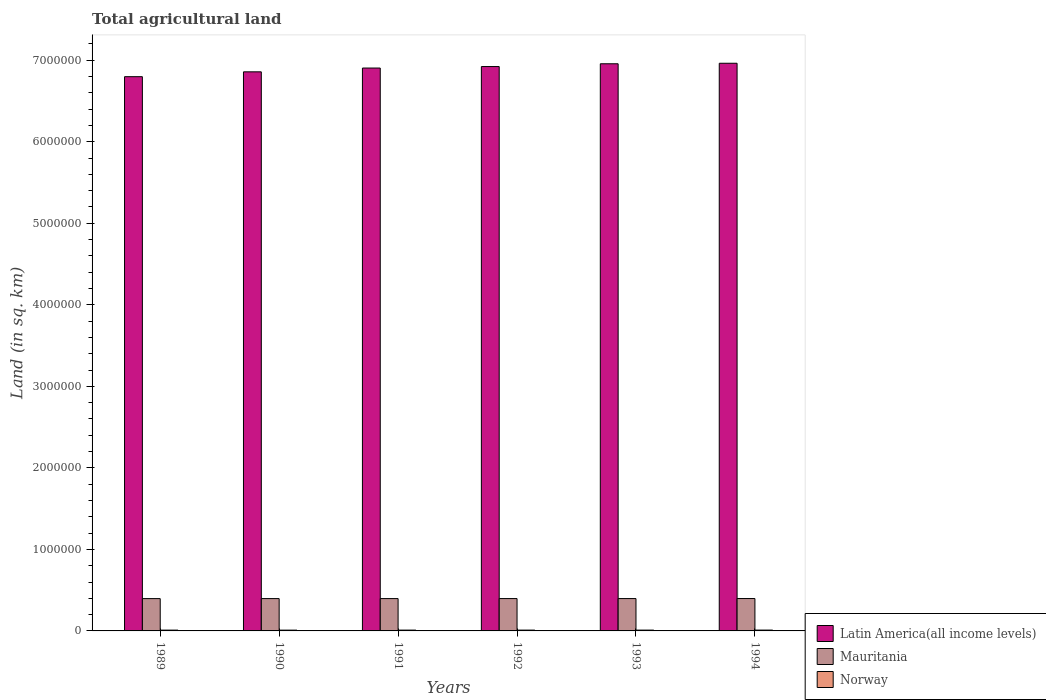How many groups of bars are there?
Keep it short and to the point. 6. How many bars are there on the 2nd tick from the left?
Offer a terse response. 3. In how many cases, is the number of bars for a given year not equal to the number of legend labels?
Make the answer very short. 0. What is the total agricultural land in Norway in 1994?
Your answer should be compact. 1.03e+04. Across all years, what is the maximum total agricultural land in Norway?
Provide a succinct answer. 1.03e+04. Across all years, what is the minimum total agricultural land in Norway?
Offer a terse response. 9760. In which year was the total agricultural land in Latin America(all income levels) minimum?
Offer a terse response. 1989. What is the total total agricultural land in Mauritania in the graph?
Provide a short and direct response. 2.38e+06. What is the difference between the total agricultural land in Latin America(all income levels) in 1990 and that in 1992?
Make the answer very short. -6.47e+04. What is the difference between the total agricultural land in Latin America(all income levels) in 1993 and the total agricultural land in Mauritania in 1990?
Keep it short and to the point. 6.56e+06. What is the average total agricultural land in Mauritania per year?
Offer a very short reply. 3.97e+05. In the year 1989, what is the difference between the total agricultural land in Mauritania and total agricultural land in Latin America(all income levels)?
Keep it short and to the point. -6.40e+06. In how many years, is the total agricultural land in Mauritania greater than 1200000 sq.km?
Provide a short and direct response. 0. What is the ratio of the total agricultural land in Latin America(all income levels) in 1990 to that in 1994?
Offer a very short reply. 0.98. Is the total agricultural land in Latin America(all income levels) in 1990 less than that in 1993?
Provide a short and direct response. Yes. What is the difference between the highest and the second highest total agricultural land in Mauritania?
Your answer should be compact. 400. What is the difference between the highest and the lowest total agricultural land in Norway?
Give a very brief answer. 540. What does the 3rd bar from the left in 1993 represents?
Your answer should be compact. Norway. What does the 1st bar from the right in 1993 represents?
Your response must be concise. Norway. Is it the case that in every year, the sum of the total agricultural land in Norway and total agricultural land in Latin America(all income levels) is greater than the total agricultural land in Mauritania?
Give a very brief answer. Yes. How many bars are there?
Give a very brief answer. 18. Are all the bars in the graph horizontal?
Make the answer very short. No. What is the difference between two consecutive major ticks on the Y-axis?
Keep it short and to the point. 1.00e+06. Are the values on the major ticks of Y-axis written in scientific E-notation?
Ensure brevity in your answer.  No. Where does the legend appear in the graph?
Provide a succinct answer. Bottom right. How are the legend labels stacked?
Offer a terse response. Vertical. What is the title of the graph?
Give a very brief answer. Total agricultural land. Does "Spain" appear as one of the legend labels in the graph?
Your response must be concise. No. What is the label or title of the X-axis?
Ensure brevity in your answer.  Years. What is the label or title of the Y-axis?
Your answer should be very brief. Land (in sq. km). What is the Land (in sq. km) in Latin America(all income levels) in 1989?
Provide a short and direct response. 6.80e+06. What is the Land (in sq. km) in Mauritania in 1989?
Your answer should be very brief. 3.96e+05. What is the Land (in sq. km) of Norway in 1989?
Offer a very short reply. 9910. What is the Land (in sq. km) in Latin America(all income levels) in 1990?
Offer a very short reply. 6.86e+06. What is the Land (in sq. km) of Mauritania in 1990?
Make the answer very short. 3.97e+05. What is the Land (in sq. km) of Norway in 1990?
Provide a succinct answer. 9760. What is the Land (in sq. km) of Latin America(all income levels) in 1991?
Ensure brevity in your answer.  6.90e+06. What is the Land (in sq. km) of Mauritania in 1991?
Your answer should be compact. 3.97e+05. What is the Land (in sq. km) in Norway in 1991?
Provide a succinct answer. 1.01e+04. What is the Land (in sq. km) in Latin America(all income levels) in 1992?
Ensure brevity in your answer.  6.92e+06. What is the Land (in sq. km) of Mauritania in 1992?
Your answer should be compact. 3.97e+05. What is the Land (in sq. km) of Norway in 1992?
Keep it short and to the point. 1.00e+04. What is the Land (in sq. km) of Latin America(all income levels) in 1993?
Give a very brief answer. 6.96e+06. What is the Land (in sq. km) of Mauritania in 1993?
Provide a short and direct response. 3.97e+05. What is the Land (in sq. km) in Norway in 1993?
Provide a short and direct response. 1.01e+04. What is the Land (in sq. km) of Latin America(all income levels) in 1994?
Keep it short and to the point. 6.96e+06. What is the Land (in sq. km) of Mauritania in 1994?
Offer a terse response. 3.97e+05. What is the Land (in sq. km) of Norway in 1994?
Offer a terse response. 1.03e+04. Across all years, what is the maximum Land (in sq. km) of Latin America(all income levels)?
Offer a terse response. 6.96e+06. Across all years, what is the maximum Land (in sq. km) of Mauritania?
Ensure brevity in your answer.  3.97e+05. Across all years, what is the maximum Land (in sq. km) in Norway?
Provide a succinct answer. 1.03e+04. Across all years, what is the minimum Land (in sq. km) in Latin America(all income levels)?
Offer a very short reply. 6.80e+06. Across all years, what is the minimum Land (in sq. km) in Mauritania?
Give a very brief answer. 3.96e+05. Across all years, what is the minimum Land (in sq. km) of Norway?
Give a very brief answer. 9760. What is the total Land (in sq. km) in Latin America(all income levels) in the graph?
Your answer should be very brief. 4.14e+07. What is the total Land (in sq. km) of Mauritania in the graph?
Offer a terse response. 2.38e+06. What is the total Land (in sq. km) in Norway in the graph?
Provide a succinct answer. 6.02e+04. What is the difference between the Land (in sq. km) of Latin America(all income levels) in 1989 and that in 1990?
Offer a terse response. -5.96e+04. What is the difference between the Land (in sq. km) of Mauritania in 1989 and that in 1990?
Offer a terse response. -210. What is the difference between the Land (in sq. km) of Norway in 1989 and that in 1990?
Give a very brief answer. 150. What is the difference between the Land (in sq. km) in Latin America(all income levels) in 1989 and that in 1991?
Make the answer very short. -1.06e+05. What is the difference between the Land (in sq. km) of Mauritania in 1989 and that in 1991?
Provide a short and direct response. -310. What is the difference between the Land (in sq. km) in Norway in 1989 and that in 1991?
Your response must be concise. -190. What is the difference between the Land (in sq. km) in Latin America(all income levels) in 1989 and that in 1992?
Offer a terse response. -1.24e+05. What is the difference between the Land (in sq. km) of Mauritania in 1989 and that in 1992?
Give a very brief answer. -430. What is the difference between the Land (in sq. km) in Norway in 1989 and that in 1992?
Keep it short and to the point. -120. What is the difference between the Land (in sq. km) in Latin America(all income levels) in 1989 and that in 1993?
Make the answer very short. -1.58e+05. What is the difference between the Land (in sq. km) in Mauritania in 1989 and that in 1993?
Provide a short and direct response. -550. What is the difference between the Land (in sq. km) in Norway in 1989 and that in 1993?
Your answer should be very brief. -220. What is the difference between the Land (in sq. km) in Latin America(all income levels) in 1989 and that in 1994?
Offer a very short reply. -1.65e+05. What is the difference between the Land (in sq. km) in Mauritania in 1989 and that in 1994?
Give a very brief answer. -950. What is the difference between the Land (in sq. km) in Norway in 1989 and that in 1994?
Ensure brevity in your answer.  -390. What is the difference between the Land (in sq. km) of Latin America(all income levels) in 1990 and that in 1991?
Your response must be concise. -4.65e+04. What is the difference between the Land (in sq. km) of Mauritania in 1990 and that in 1991?
Your response must be concise. -100. What is the difference between the Land (in sq. km) of Norway in 1990 and that in 1991?
Ensure brevity in your answer.  -340. What is the difference between the Land (in sq. km) in Latin America(all income levels) in 1990 and that in 1992?
Offer a terse response. -6.47e+04. What is the difference between the Land (in sq. km) in Mauritania in 1990 and that in 1992?
Give a very brief answer. -220. What is the difference between the Land (in sq. km) in Norway in 1990 and that in 1992?
Your answer should be very brief. -270. What is the difference between the Land (in sq. km) of Latin America(all income levels) in 1990 and that in 1993?
Offer a terse response. -9.88e+04. What is the difference between the Land (in sq. km) of Mauritania in 1990 and that in 1993?
Your response must be concise. -340. What is the difference between the Land (in sq. km) in Norway in 1990 and that in 1993?
Your answer should be very brief. -370. What is the difference between the Land (in sq. km) in Latin America(all income levels) in 1990 and that in 1994?
Your response must be concise. -1.05e+05. What is the difference between the Land (in sq. km) of Mauritania in 1990 and that in 1994?
Offer a terse response. -740. What is the difference between the Land (in sq. km) of Norway in 1990 and that in 1994?
Your answer should be compact. -540. What is the difference between the Land (in sq. km) of Latin America(all income levels) in 1991 and that in 1992?
Give a very brief answer. -1.82e+04. What is the difference between the Land (in sq. km) of Mauritania in 1991 and that in 1992?
Keep it short and to the point. -120. What is the difference between the Land (in sq. km) in Latin America(all income levels) in 1991 and that in 1993?
Your answer should be compact. -5.23e+04. What is the difference between the Land (in sq. km) in Mauritania in 1991 and that in 1993?
Keep it short and to the point. -240. What is the difference between the Land (in sq. km) of Norway in 1991 and that in 1993?
Ensure brevity in your answer.  -30. What is the difference between the Land (in sq. km) of Latin America(all income levels) in 1991 and that in 1994?
Make the answer very short. -5.86e+04. What is the difference between the Land (in sq. km) in Mauritania in 1991 and that in 1994?
Your response must be concise. -640. What is the difference between the Land (in sq. km) in Norway in 1991 and that in 1994?
Offer a very short reply. -200. What is the difference between the Land (in sq. km) in Latin America(all income levels) in 1992 and that in 1993?
Keep it short and to the point. -3.41e+04. What is the difference between the Land (in sq. km) in Mauritania in 1992 and that in 1993?
Ensure brevity in your answer.  -120. What is the difference between the Land (in sq. km) of Norway in 1992 and that in 1993?
Your answer should be compact. -100. What is the difference between the Land (in sq. km) of Latin America(all income levels) in 1992 and that in 1994?
Give a very brief answer. -4.04e+04. What is the difference between the Land (in sq. km) of Mauritania in 1992 and that in 1994?
Provide a short and direct response. -520. What is the difference between the Land (in sq. km) of Norway in 1992 and that in 1994?
Your answer should be compact. -270. What is the difference between the Land (in sq. km) in Latin America(all income levels) in 1993 and that in 1994?
Your answer should be very brief. -6297. What is the difference between the Land (in sq. km) of Mauritania in 1993 and that in 1994?
Offer a very short reply. -400. What is the difference between the Land (in sq. km) in Norway in 1993 and that in 1994?
Your response must be concise. -170. What is the difference between the Land (in sq. km) of Latin America(all income levels) in 1989 and the Land (in sq. km) of Mauritania in 1990?
Ensure brevity in your answer.  6.40e+06. What is the difference between the Land (in sq. km) of Latin America(all income levels) in 1989 and the Land (in sq. km) of Norway in 1990?
Your answer should be very brief. 6.79e+06. What is the difference between the Land (in sq. km) in Mauritania in 1989 and the Land (in sq. km) in Norway in 1990?
Ensure brevity in your answer.  3.87e+05. What is the difference between the Land (in sq. km) in Latin America(all income levels) in 1989 and the Land (in sq. km) in Mauritania in 1991?
Your answer should be very brief. 6.40e+06. What is the difference between the Land (in sq. km) of Latin America(all income levels) in 1989 and the Land (in sq. km) of Norway in 1991?
Your answer should be very brief. 6.79e+06. What is the difference between the Land (in sq. km) in Mauritania in 1989 and the Land (in sq. km) in Norway in 1991?
Give a very brief answer. 3.86e+05. What is the difference between the Land (in sq. km) of Latin America(all income levels) in 1989 and the Land (in sq. km) of Mauritania in 1992?
Make the answer very short. 6.40e+06. What is the difference between the Land (in sq. km) in Latin America(all income levels) in 1989 and the Land (in sq. km) in Norway in 1992?
Provide a succinct answer. 6.79e+06. What is the difference between the Land (in sq. km) of Mauritania in 1989 and the Land (in sq. km) of Norway in 1992?
Provide a succinct answer. 3.86e+05. What is the difference between the Land (in sq. km) of Latin America(all income levels) in 1989 and the Land (in sq. km) of Mauritania in 1993?
Your answer should be compact. 6.40e+06. What is the difference between the Land (in sq. km) in Latin America(all income levels) in 1989 and the Land (in sq. km) in Norway in 1993?
Your answer should be compact. 6.79e+06. What is the difference between the Land (in sq. km) in Mauritania in 1989 and the Land (in sq. km) in Norway in 1993?
Ensure brevity in your answer.  3.86e+05. What is the difference between the Land (in sq. km) in Latin America(all income levels) in 1989 and the Land (in sq. km) in Mauritania in 1994?
Ensure brevity in your answer.  6.40e+06. What is the difference between the Land (in sq. km) of Latin America(all income levels) in 1989 and the Land (in sq. km) of Norway in 1994?
Give a very brief answer. 6.79e+06. What is the difference between the Land (in sq. km) in Mauritania in 1989 and the Land (in sq. km) in Norway in 1994?
Your answer should be very brief. 3.86e+05. What is the difference between the Land (in sq. km) in Latin America(all income levels) in 1990 and the Land (in sq. km) in Mauritania in 1991?
Make the answer very short. 6.46e+06. What is the difference between the Land (in sq. km) of Latin America(all income levels) in 1990 and the Land (in sq. km) of Norway in 1991?
Offer a terse response. 6.85e+06. What is the difference between the Land (in sq. km) of Mauritania in 1990 and the Land (in sq. km) of Norway in 1991?
Give a very brief answer. 3.86e+05. What is the difference between the Land (in sq. km) of Latin America(all income levels) in 1990 and the Land (in sq. km) of Mauritania in 1992?
Provide a succinct answer. 6.46e+06. What is the difference between the Land (in sq. km) in Latin America(all income levels) in 1990 and the Land (in sq. km) in Norway in 1992?
Give a very brief answer. 6.85e+06. What is the difference between the Land (in sq. km) of Mauritania in 1990 and the Land (in sq. km) of Norway in 1992?
Your answer should be compact. 3.87e+05. What is the difference between the Land (in sq. km) in Latin America(all income levels) in 1990 and the Land (in sq. km) in Mauritania in 1993?
Offer a terse response. 6.46e+06. What is the difference between the Land (in sq. km) of Latin America(all income levels) in 1990 and the Land (in sq. km) of Norway in 1993?
Ensure brevity in your answer.  6.85e+06. What is the difference between the Land (in sq. km) in Mauritania in 1990 and the Land (in sq. km) in Norway in 1993?
Your answer should be very brief. 3.86e+05. What is the difference between the Land (in sq. km) in Latin America(all income levels) in 1990 and the Land (in sq. km) in Mauritania in 1994?
Offer a very short reply. 6.46e+06. What is the difference between the Land (in sq. km) in Latin America(all income levels) in 1990 and the Land (in sq. km) in Norway in 1994?
Give a very brief answer. 6.85e+06. What is the difference between the Land (in sq. km) of Mauritania in 1990 and the Land (in sq. km) of Norway in 1994?
Provide a succinct answer. 3.86e+05. What is the difference between the Land (in sq. km) of Latin America(all income levels) in 1991 and the Land (in sq. km) of Mauritania in 1992?
Your answer should be very brief. 6.51e+06. What is the difference between the Land (in sq. km) in Latin America(all income levels) in 1991 and the Land (in sq. km) in Norway in 1992?
Keep it short and to the point. 6.89e+06. What is the difference between the Land (in sq. km) in Mauritania in 1991 and the Land (in sq. km) in Norway in 1992?
Keep it short and to the point. 3.87e+05. What is the difference between the Land (in sq. km) of Latin America(all income levels) in 1991 and the Land (in sq. km) of Mauritania in 1993?
Give a very brief answer. 6.51e+06. What is the difference between the Land (in sq. km) in Latin America(all income levels) in 1991 and the Land (in sq. km) in Norway in 1993?
Make the answer very short. 6.89e+06. What is the difference between the Land (in sq. km) in Mauritania in 1991 and the Land (in sq. km) in Norway in 1993?
Your response must be concise. 3.87e+05. What is the difference between the Land (in sq. km) in Latin America(all income levels) in 1991 and the Land (in sq. km) in Mauritania in 1994?
Make the answer very short. 6.51e+06. What is the difference between the Land (in sq. km) in Latin America(all income levels) in 1991 and the Land (in sq. km) in Norway in 1994?
Provide a succinct answer. 6.89e+06. What is the difference between the Land (in sq. km) in Mauritania in 1991 and the Land (in sq. km) in Norway in 1994?
Provide a succinct answer. 3.86e+05. What is the difference between the Land (in sq. km) in Latin America(all income levels) in 1992 and the Land (in sq. km) in Mauritania in 1993?
Your answer should be compact. 6.53e+06. What is the difference between the Land (in sq. km) in Latin America(all income levels) in 1992 and the Land (in sq. km) in Norway in 1993?
Keep it short and to the point. 6.91e+06. What is the difference between the Land (in sq. km) of Mauritania in 1992 and the Land (in sq. km) of Norway in 1993?
Make the answer very short. 3.87e+05. What is the difference between the Land (in sq. km) in Latin America(all income levels) in 1992 and the Land (in sq. km) in Mauritania in 1994?
Provide a succinct answer. 6.53e+06. What is the difference between the Land (in sq. km) of Latin America(all income levels) in 1992 and the Land (in sq. km) of Norway in 1994?
Provide a succinct answer. 6.91e+06. What is the difference between the Land (in sq. km) of Mauritania in 1992 and the Land (in sq. km) of Norway in 1994?
Make the answer very short. 3.86e+05. What is the difference between the Land (in sq. km) of Latin America(all income levels) in 1993 and the Land (in sq. km) of Mauritania in 1994?
Make the answer very short. 6.56e+06. What is the difference between the Land (in sq. km) in Latin America(all income levels) in 1993 and the Land (in sq. km) in Norway in 1994?
Make the answer very short. 6.95e+06. What is the difference between the Land (in sq. km) of Mauritania in 1993 and the Land (in sq. km) of Norway in 1994?
Provide a succinct answer. 3.87e+05. What is the average Land (in sq. km) in Latin America(all income levels) per year?
Give a very brief answer. 6.90e+06. What is the average Land (in sq. km) in Mauritania per year?
Provide a short and direct response. 3.97e+05. What is the average Land (in sq. km) in Norway per year?
Provide a succinct answer. 1.00e+04. In the year 1989, what is the difference between the Land (in sq. km) of Latin America(all income levels) and Land (in sq. km) of Mauritania?
Make the answer very short. 6.40e+06. In the year 1989, what is the difference between the Land (in sq. km) of Latin America(all income levels) and Land (in sq. km) of Norway?
Give a very brief answer. 6.79e+06. In the year 1989, what is the difference between the Land (in sq. km) of Mauritania and Land (in sq. km) of Norway?
Provide a short and direct response. 3.86e+05. In the year 1990, what is the difference between the Land (in sq. km) of Latin America(all income levels) and Land (in sq. km) of Mauritania?
Offer a terse response. 6.46e+06. In the year 1990, what is the difference between the Land (in sq. km) of Latin America(all income levels) and Land (in sq. km) of Norway?
Ensure brevity in your answer.  6.85e+06. In the year 1990, what is the difference between the Land (in sq. km) of Mauritania and Land (in sq. km) of Norway?
Provide a succinct answer. 3.87e+05. In the year 1991, what is the difference between the Land (in sq. km) of Latin America(all income levels) and Land (in sq. km) of Mauritania?
Provide a succinct answer. 6.51e+06. In the year 1991, what is the difference between the Land (in sq. km) of Latin America(all income levels) and Land (in sq. km) of Norway?
Your response must be concise. 6.89e+06. In the year 1991, what is the difference between the Land (in sq. km) of Mauritania and Land (in sq. km) of Norway?
Ensure brevity in your answer.  3.87e+05. In the year 1992, what is the difference between the Land (in sq. km) of Latin America(all income levels) and Land (in sq. km) of Mauritania?
Offer a very short reply. 6.53e+06. In the year 1992, what is the difference between the Land (in sq. km) of Latin America(all income levels) and Land (in sq. km) of Norway?
Your response must be concise. 6.91e+06. In the year 1992, what is the difference between the Land (in sq. km) of Mauritania and Land (in sq. km) of Norway?
Offer a very short reply. 3.87e+05. In the year 1993, what is the difference between the Land (in sq. km) in Latin America(all income levels) and Land (in sq. km) in Mauritania?
Your response must be concise. 6.56e+06. In the year 1993, what is the difference between the Land (in sq. km) of Latin America(all income levels) and Land (in sq. km) of Norway?
Your answer should be compact. 6.95e+06. In the year 1993, what is the difference between the Land (in sq. km) in Mauritania and Land (in sq. km) in Norway?
Make the answer very short. 3.87e+05. In the year 1994, what is the difference between the Land (in sq. km) of Latin America(all income levels) and Land (in sq. km) of Mauritania?
Provide a short and direct response. 6.57e+06. In the year 1994, what is the difference between the Land (in sq. km) of Latin America(all income levels) and Land (in sq. km) of Norway?
Offer a very short reply. 6.95e+06. In the year 1994, what is the difference between the Land (in sq. km) in Mauritania and Land (in sq. km) in Norway?
Your response must be concise. 3.87e+05. What is the ratio of the Land (in sq. km) in Mauritania in 1989 to that in 1990?
Your answer should be compact. 1. What is the ratio of the Land (in sq. km) in Norway in 1989 to that in 1990?
Your answer should be very brief. 1.02. What is the ratio of the Land (in sq. km) of Latin America(all income levels) in 1989 to that in 1991?
Your answer should be very brief. 0.98. What is the ratio of the Land (in sq. km) of Mauritania in 1989 to that in 1991?
Ensure brevity in your answer.  1. What is the ratio of the Land (in sq. km) in Norway in 1989 to that in 1991?
Your answer should be compact. 0.98. What is the ratio of the Land (in sq. km) in Mauritania in 1989 to that in 1992?
Keep it short and to the point. 1. What is the ratio of the Land (in sq. km) of Latin America(all income levels) in 1989 to that in 1993?
Your response must be concise. 0.98. What is the ratio of the Land (in sq. km) of Norway in 1989 to that in 1993?
Offer a terse response. 0.98. What is the ratio of the Land (in sq. km) of Latin America(all income levels) in 1989 to that in 1994?
Your answer should be very brief. 0.98. What is the ratio of the Land (in sq. km) in Mauritania in 1989 to that in 1994?
Make the answer very short. 1. What is the ratio of the Land (in sq. km) of Norway in 1989 to that in 1994?
Provide a succinct answer. 0.96. What is the ratio of the Land (in sq. km) in Mauritania in 1990 to that in 1991?
Keep it short and to the point. 1. What is the ratio of the Land (in sq. km) in Norway in 1990 to that in 1991?
Offer a terse response. 0.97. What is the ratio of the Land (in sq. km) of Latin America(all income levels) in 1990 to that in 1992?
Make the answer very short. 0.99. What is the ratio of the Land (in sq. km) of Norway in 1990 to that in 1992?
Make the answer very short. 0.97. What is the ratio of the Land (in sq. km) in Latin America(all income levels) in 1990 to that in 1993?
Offer a terse response. 0.99. What is the ratio of the Land (in sq. km) in Norway in 1990 to that in 1993?
Ensure brevity in your answer.  0.96. What is the ratio of the Land (in sq. km) of Latin America(all income levels) in 1990 to that in 1994?
Provide a short and direct response. 0.98. What is the ratio of the Land (in sq. km) in Mauritania in 1990 to that in 1994?
Give a very brief answer. 1. What is the ratio of the Land (in sq. km) in Norway in 1990 to that in 1994?
Offer a very short reply. 0.95. What is the ratio of the Land (in sq. km) of Latin America(all income levels) in 1991 to that in 1992?
Offer a very short reply. 1. What is the ratio of the Land (in sq. km) in Norway in 1991 to that in 1993?
Your response must be concise. 1. What is the ratio of the Land (in sq. km) of Mauritania in 1991 to that in 1994?
Provide a short and direct response. 1. What is the ratio of the Land (in sq. km) in Norway in 1991 to that in 1994?
Offer a very short reply. 0.98. What is the ratio of the Land (in sq. km) of Latin America(all income levels) in 1992 to that in 1993?
Your response must be concise. 1. What is the ratio of the Land (in sq. km) in Mauritania in 1992 to that in 1993?
Keep it short and to the point. 1. What is the ratio of the Land (in sq. km) in Norway in 1992 to that in 1993?
Make the answer very short. 0.99. What is the ratio of the Land (in sq. km) in Latin America(all income levels) in 1992 to that in 1994?
Your response must be concise. 0.99. What is the ratio of the Land (in sq. km) in Norway in 1992 to that in 1994?
Give a very brief answer. 0.97. What is the ratio of the Land (in sq. km) in Mauritania in 1993 to that in 1994?
Provide a succinct answer. 1. What is the ratio of the Land (in sq. km) in Norway in 1993 to that in 1994?
Keep it short and to the point. 0.98. What is the difference between the highest and the second highest Land (in sq. km) in Latin America(all income levels)?
Make the answer very short. 6297. What is the difference between the highest and the second highest Land (in sq. km) of Mauritania?
Make the answer very short. 400. What is the difference between the highest and the second highest Land (in sq. km) in Norway?
Provide a succinct answer. 170. What is the difference between the highest and the lowest Land (in sq. km) of Latin America(all income levels)?
Give a very brief answer. 1.65e+05. What is the difference between the highest and the lowest Land (in sq. km) of Mauritania?
Offer a very short reply. 950. What is the difference between the highest and the lowest Land (in sq. km) of Norway?
Provide a succinct answer. 540. 